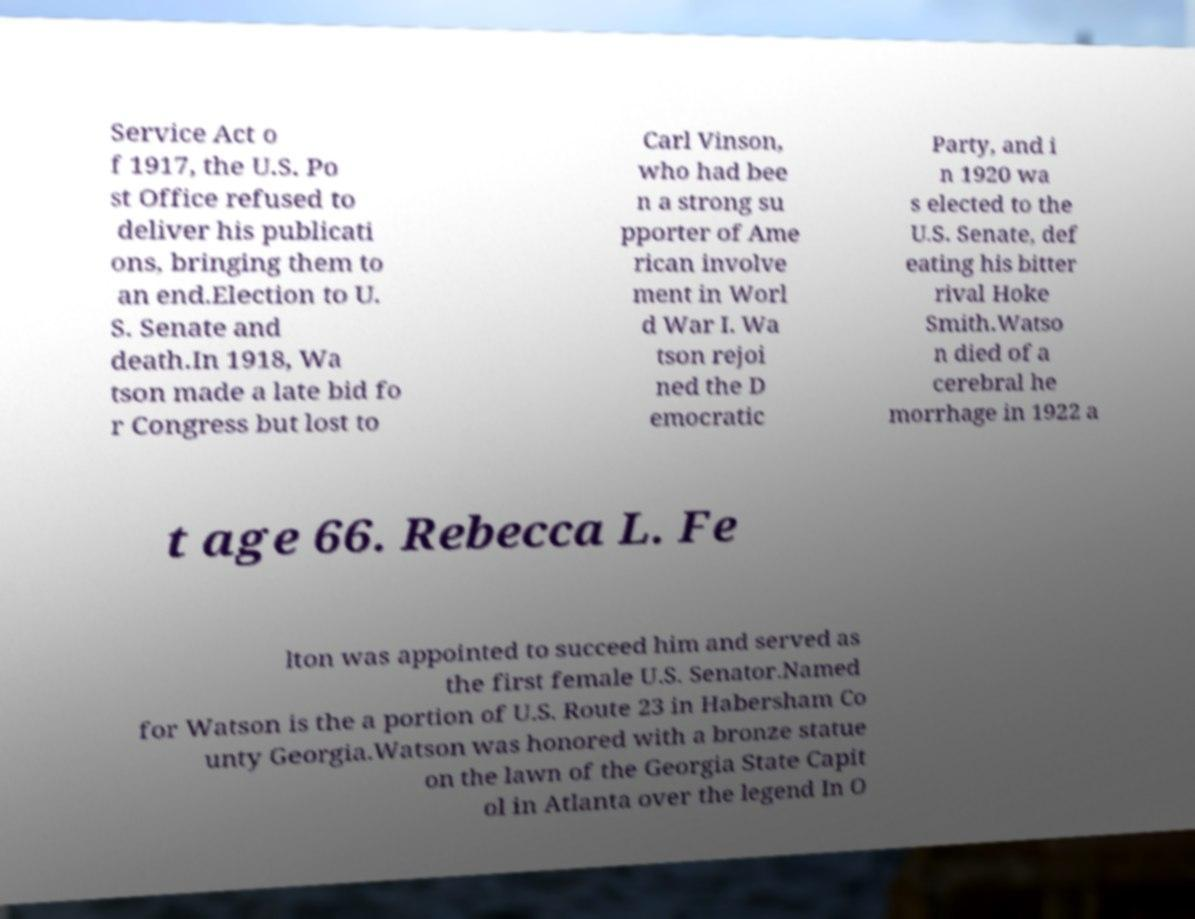What messages or text are displayed in this image? I need them in a readable, typed format. Service Act o f 1917, the U.S. Po st Office refused to deliver his publicati ons, bringing them to an end.Election to U. S. Senate and death.In 1918, Wa tson made a late bid fo r Congress but lost to Carl Vinson, who had bee n a strong su pporter of Ame rican involve ment in Worl d War I. Wa tson rejoi ned the D emocratic Party, and i n 1920 wa s elected to the U.S. Senate, def eating his bitter rival Hoke Smith.Watso n died of a cerebral he morrhage in 1922 a t age 66. Rebecca L. Fe lton was appointed to succeed him and served as the first female U.S. Senator.Named for Watson is the a portion of U.S. Route 23 in Habersham Co unty Georgia.Watson was honored with a bronze statue on the lawn of the Georgia State Capit ol in Atlanta over the legend In O 